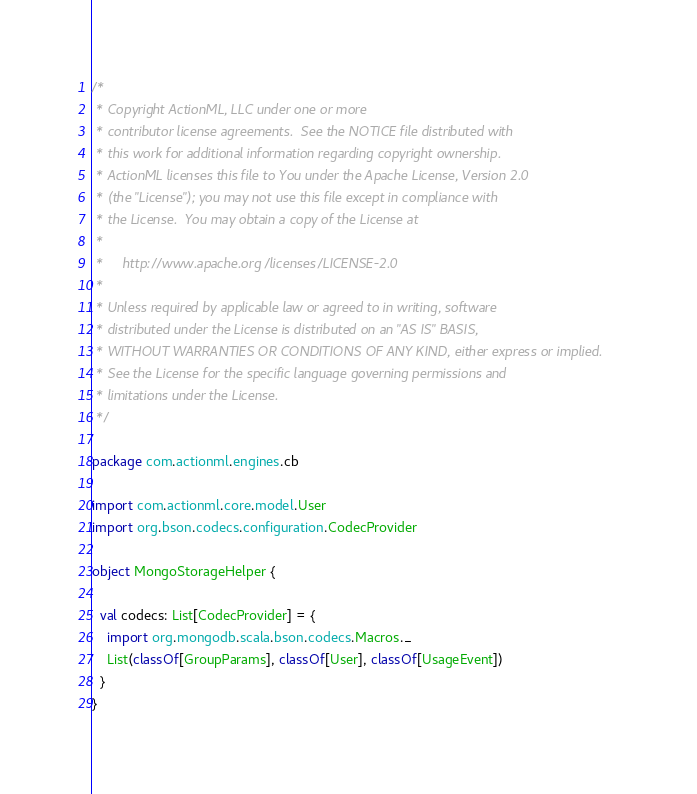<code> <loc_0><loc_0><loc_500><loc_500><_Scala_>/*
 * Copyright ActionML, LLC under one or more
 * contributor license agreements.  See the NOTICE file distributed with
 * this work for additional information regarding copyright ownership.
 * ActionML licenses this file to You under the Apache License, Version 2.0
 * (the "License"); you may not use this file except in compliance with
 * the License.  You may obtain a copy of the License at
 *
 *     http://www.apache.org/licenses/LICENSE-2.0
 *
 * Unless required by applicable law or agreed to in writing, software
 * distributed under the License is distributed on an "AS IS" BASIS,
 * WITHOUT WARRANTIES OR CONDITIONS OF ANY KIND, either express or implied.
 * See the License for the specific language governing permissions and
 * limitations under the License.
 */

package com.actionml.engines.cb

import com.actionml.core.model.User
import org.bson.codecs.configuration.CodecProvider

object MongoStorageHelper {

  val codecs: List[CodecProvider] = {
    import org.mongodb.scala.bson.codecs.Macros._
    List(classOf[GroupParams], classOf[User], classOf[UsageEvent])
  }
}
</code> 